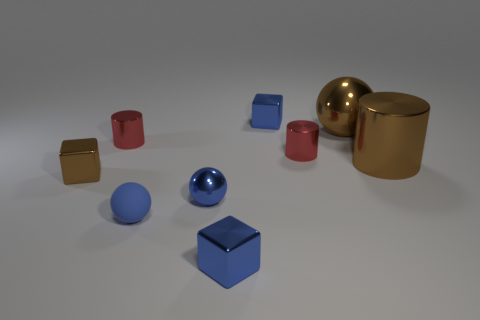Subtract all cubes. How many objects are left? 6 Add 6 rubber things. How many rubber things exist? 7 Subtract 1 blue balls. How many objects are left? 8 Subtract all big red shiny things. Subtract all brown blocks. How many objects are left? 8 Add 1 small blue balls. How many small blue balls are left? 3 